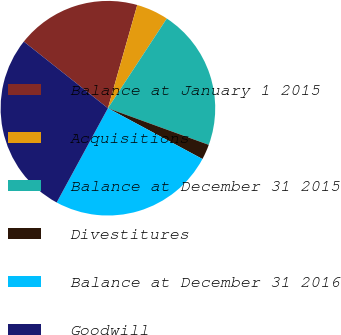Convert chart. <chart><loc_0><loc_0><loc_500><loc_500><pie_chart><fcel>Balance at January 1 2015<fcel>Acquisitions<fcel>Balance at December 31 2015<fcel>Divestitures<fcel>Balance at December 31 2016<fcel>Goodwill<nl><fcel>18.75%<fcel>4.84%<fcel>21.3%<fcel>2.3%<fcel>25.08%<fcel>27.74%<nl></chart> 